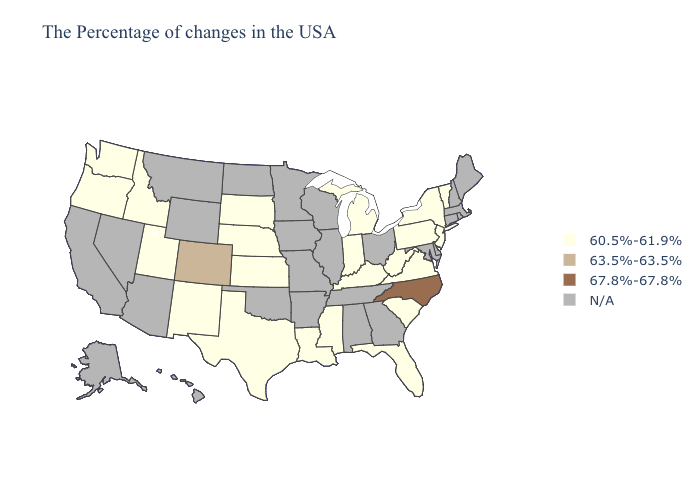Name the states that have a value in the range N/A?
Quick response, please. Maine, Massachusetts, Rhode Island, New Hampshire, Connecticut, Delaware, Maryland, Ohio, Georgia, Alabama, Tennessee, Wisconsin, Illinois, Missouri, Arkansas, Minnesota, Iowa, Oklahoma, North Dakota, Wyoming, Montana, Arizona, Nevada, California, Alaska, Hawaii. Which states have the highest value in the USA?
Answer briefly. North Carolina. Name the states that have a value in the range 67.8%-67.8%?
Be succinct. North Carolina. Name the states that have a value in the range N/A?
Quick response, please. Maine, Massachusetts, Rhode Island, New Hampshire, Connecticut, Delaware, Maryland, Ohio, Georgia, Alabama, Tennessee, Wisconsin, Illinois, Missouri, Arkansas, Minnesota, Iowa, Oklahoma, North Dakota, Wyoming, Montana, Arizona, Nevada, California, Alaska, Hawaii. Among the states that border Utah , which have the lowest value?
Short answer required. New Mexico, Idaho. Name the states that have a value in the range 60.5%-61.9%?
Quick response, please. Vermont, New York, New Jersey, Pennsylvania, Virginia, South Carolina, West Virginia, Florida, Michigan, Kentucky, Indiana, Mississippi, Louisiana, Kansas, Nebraska, Texas, South Dakota, New Mexico, Utah, Idaho, Washington, Oregon. Name the states that have a value in the range N/A?
Write a very short answer. Maine, Massachusetts, Rhode Island, New Hampshire, Connecticut, Delaware, Maryland, Ohio, Georgia, Alabama, Tennessee, Wisconsin, Illinois, Missouri, Arkansas, Minnesota, Iowa, Oklahoma, North Dakota, Wyoming, Montana, Arizona, Nevada, California, Alaska, Hawaii. What is the value of West Virginia?
Write a very short answer. 60.5%-61.9%. Which states have the highest value in the USA?
Quick response, please. North Carolina. Does Kansas have the lowest value in the USA?
Quick response, please. Yes. What is the lowest value in the South?
Answer briefly. 60.5%-61.9%. Which states hav the highest value in the Northeast?
Give a very brief answer. Vermont, New York, New Jersey, Pennsylvania. Name the states that have a value in the range 63.5%-63.5%?
Give a very brief answer. Colorado. What is the value of Kansas?
Be succinct. 60.5%-61.9%. 